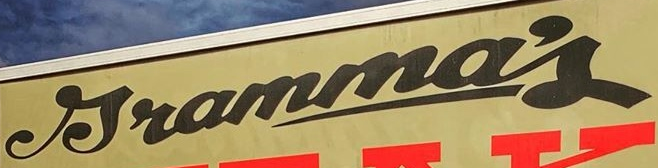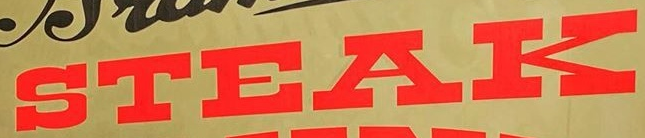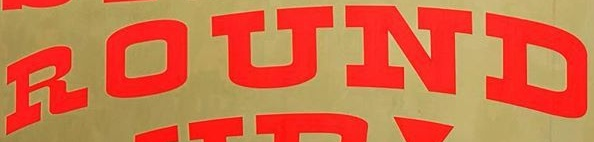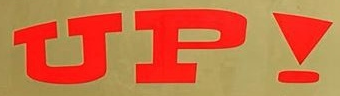What text is displayed in these images sequentially, separated by a semicolon? Jramma's; STEAK; ROUND; UP! 